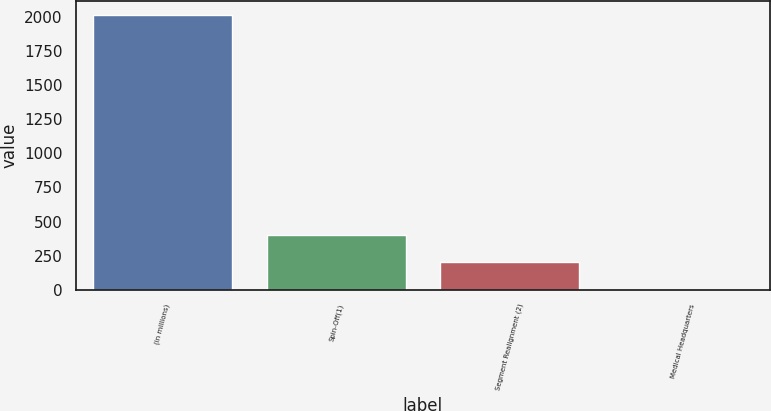<chart> <loc_0><loc_0><loc_500><loc_500><bar_chart><fcel>(in millions)<fcel>Spin-Off(1)<fcel>Segment Realignment (2)<fcel>Medical Headquarters<nl><fcel>2010<fcel>402.08<fcel>201.09<fcel>0.1<nl></chart> 